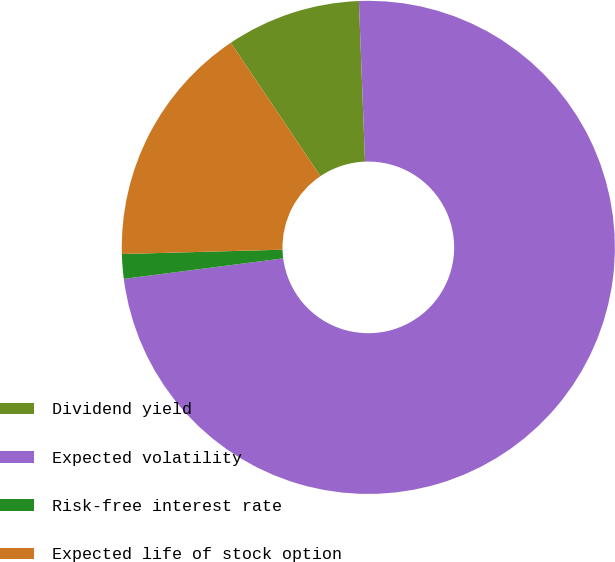Convert chart. <chart><loc_0><loc_0><loc_500><loc_500><pie_chart><fcel>Dividend yield<fcel>Expected volatility<fcel>Risk-free interest rate<fcel>Expected life of stock option<nl><fcel>8.81%<fcel>73.57%<fcel>1.61%<fcel>16.01%<nl></chart> 